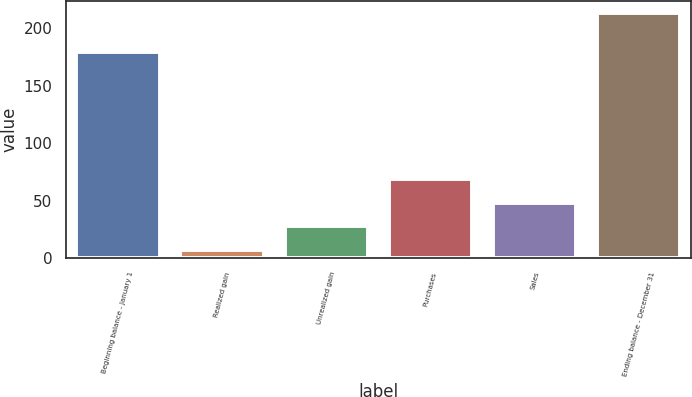Convert chart to OTSL. <chart><loc_0><loc_0><loc_500><loc_500><bar_chart><fcel>Beginning balance - January 1<fcel>Realized gain<fcel>Unrealized gain<fcel>Purchases<fcel>Sales<fcel>Ending balance - December 31<nl><fcel>179<fcel>7<fcel>27.6<fcel>68.8<fcel>48.2<fcel>213<nl></chart> 